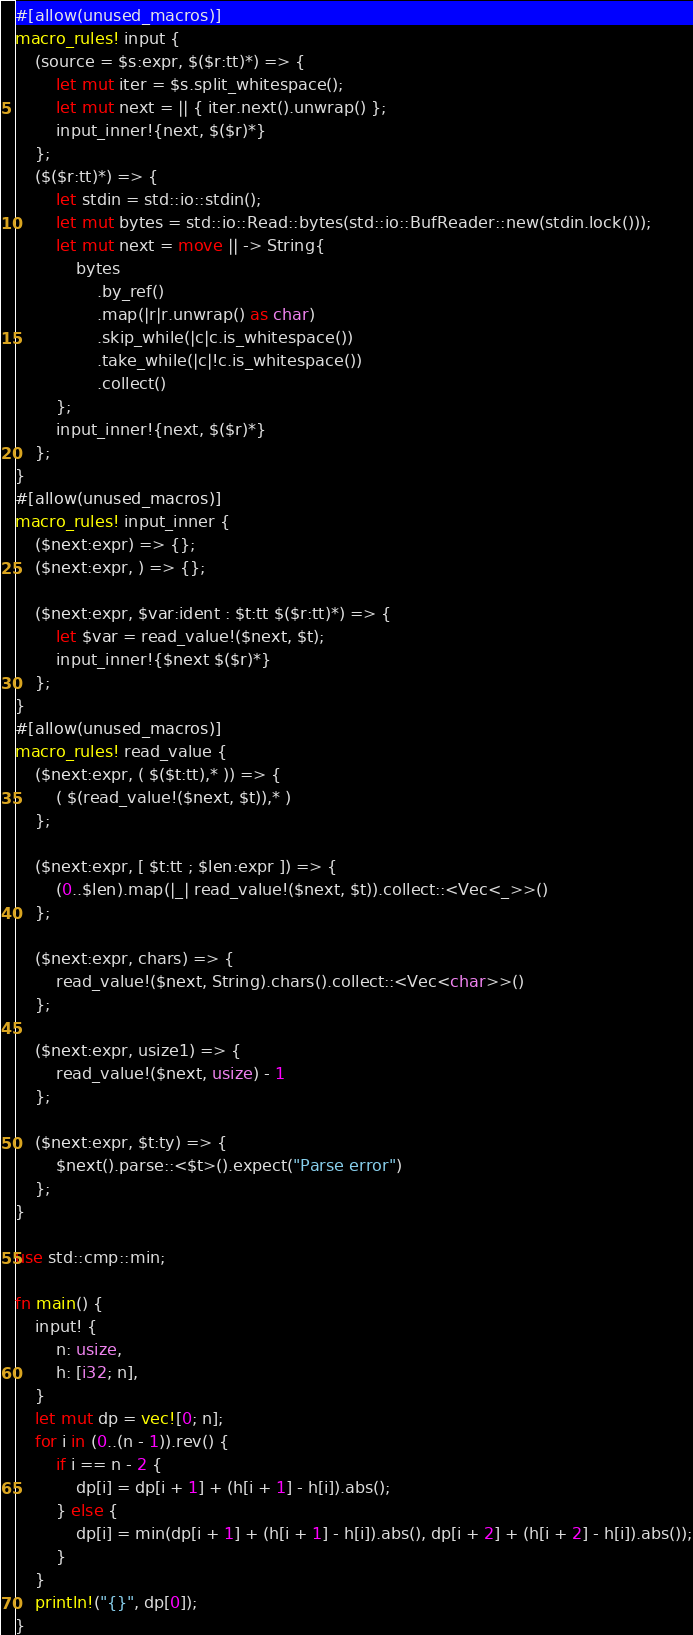Convert code to text. <code><loc_0><loc_0><loc_500><loc_500><_Rust_>#[allow(unused_macros)]
macro_rules! input {
    (source = $s:expr, $($r:tt)*) => {
        let mut iter = $s.split_whitespace();
        let mut next = || { iter.next().unwrap() };
        input_inner!{next, $($r)*}
    };
    ($($r:tt)*) => {
        let stdin = std::io::stdin();
        let mut bytes = std::io::Read::bytes(std::io::BufReader::new(stdin.lock()));
        let mut next = move || -> String{
            bytes
                .by_ref()
                .map(|r|r.unwrap() as char)
                .skip_while(|c|c.is_whitespace())
                .take_while(|c|!c.is_whitespace())
                .collect()
        };
        input_inner!{next, $($r)*}
    };
}
#[allow(unused_macros)]
macro_rules! input_inner {
    ($next:expr) => {};
    ($next:expr, ) => {};

    ($next:expr, $var:ident : $t:tt $($r:tt)*) => {
        let $var = read_value!($next, $t);
        input_inner!{$next $($r)*}
    };
}
#[allow(unused_macros)]
macro_rules! read_value {
    ($next:expr, ( $($t:tt),* )) => {
        ( $(read_value!($next, $t)),* )
    };

    ($next:expr, [ $t:tt ; $len:expr ]) => {
        (0..$len).map(|_| read_value!($next, $t)).collect::<Vec<_>>()
    };

    ($next:expr, chars) => {
        read_value!($next, String).chars().collect::<Vec<char>>()
    };

    ($next:expr, usize1) => {
        read_value!($next, usize) - 1
    };

    ($next:expr, $t:ty) => {
        $next().parse::<$t>().expect("Parse error")
    };
}

use std::cmp::min;

fn main() {
    input! {
        n: usize,
        h: [i32; n],
    }
    let mut dp = vec![0; n];
    for i in (0..(n - 1)).rev() {
        if i == n - 2 {
            dp[i] = dp[i + 1] + (h[i + 1] - h[i]).abs();
        } else {
            dp[i] = min(dp[i + 1] + (h[i + 1] - h[i]).abs(), dp[i + 2] + (h[i + 2] - h[i]).abs());
        }
    }
    println!("{}", dp[0]);
} 
</code> 